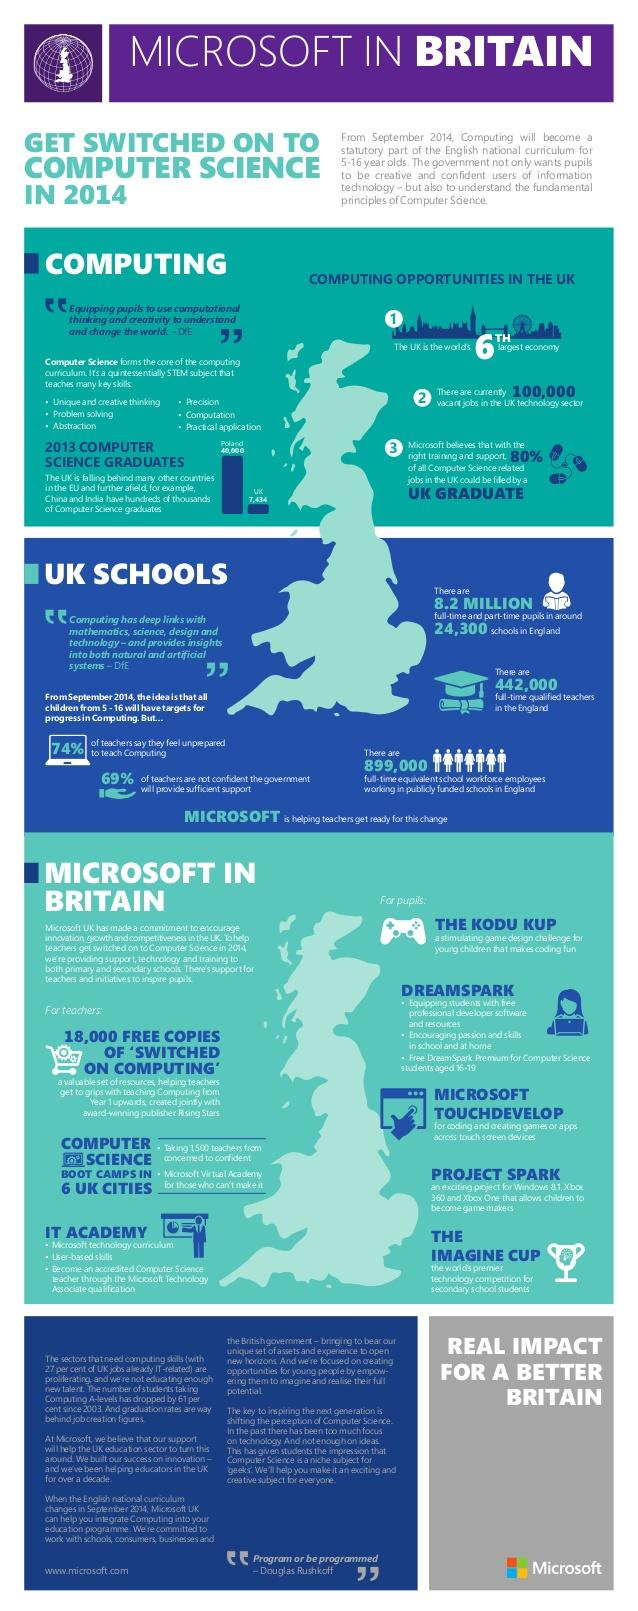Identify some key points in this picture. Microsoft is engaged in three main activities for teachers in the UK. Computing has strong connections with subjects such as mathematics, science, design and technology. It is possible to earn an accredited Bachelor's degree in Computer Science at the IT Academy. Computer science teaches six key skills. In 2013, Poland had more computer science graduates than the UK, with a total of 32,566, while the UK had 28,100 graduates in the same field. 